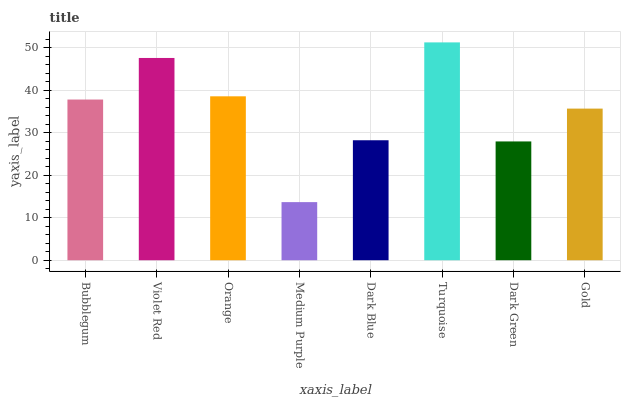Is Medium Purple the minimum?
Answer yes or no. Yes. Is Turquoise the maximum?
Answer yes or no. Yes. Is Violet Red the minimum?
Answer yes or no. No. Is Violet Red the maximum?
Answer yes or no. No. Is Violet Red greater than Bubblegum?
Answer yes or no. Yes. Is Bubblegum less than Violet Red?
Answer yes or no. Yes. Is Bubblegum greater than Violet Red?
Answer yes or no. No. Is Violet Red less than Bubblegum?
Answer yes or no. No. Is Bubblegum the high median?
Answer yes or no. Yes. Is Gold the low median?
Answer yes or no. Yes. Is Violet Red the high median?
Answer yes or no. No. Is Bubblegum the low median?
Answer yes or no. No. 